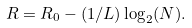<formula> <loc_0><loc_0><loc_500><loc_500>R = R _ { 0 } - ( 1 / L ) \log _ { 2 } ( N ) .</formula> 